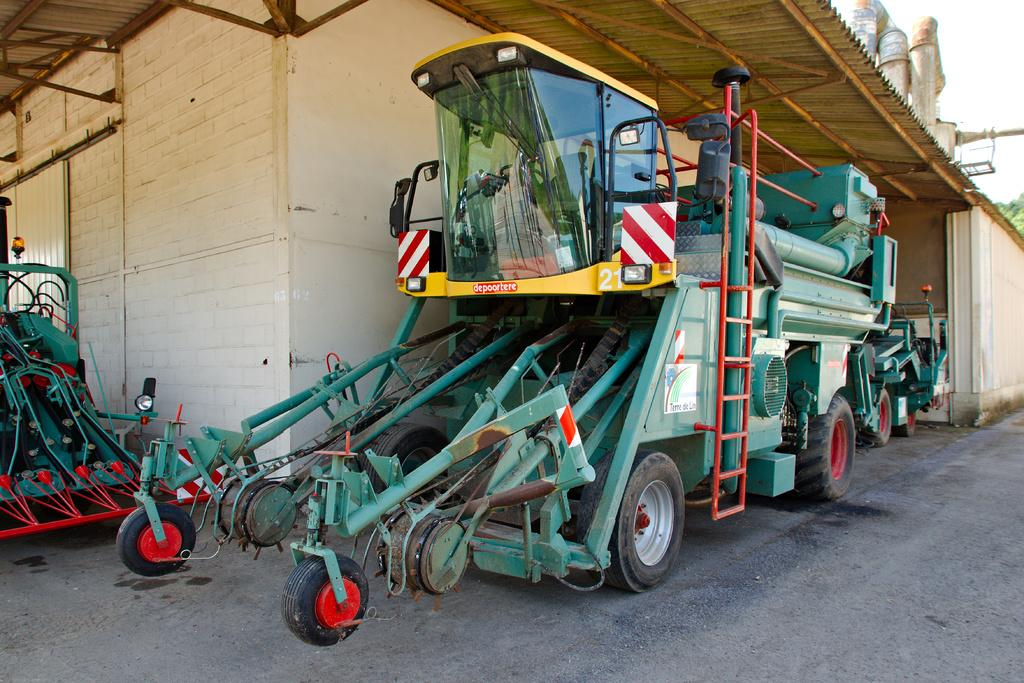What type of vehicle is in the image? There is a vehicle in the image, and it has a ladder. What can be seen in the background of the image? There is a building in the background of the image. How many leaves are on the snail in the image? There is no snail or leaves present in the image. Did the earthquake cause any damage to the vehicle in the image? There is no mention of an earthquake in the image, and no damage is visible on the vehicle. 